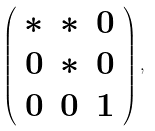<formula> <loc_0><loc_0><loc_500><loc_500>\left ( \begin{array} { c c c } * & * & 0 \\ 0 & * & 0 \\ 0 & 0 & 1 \end{array} \right ) ,</formula> 